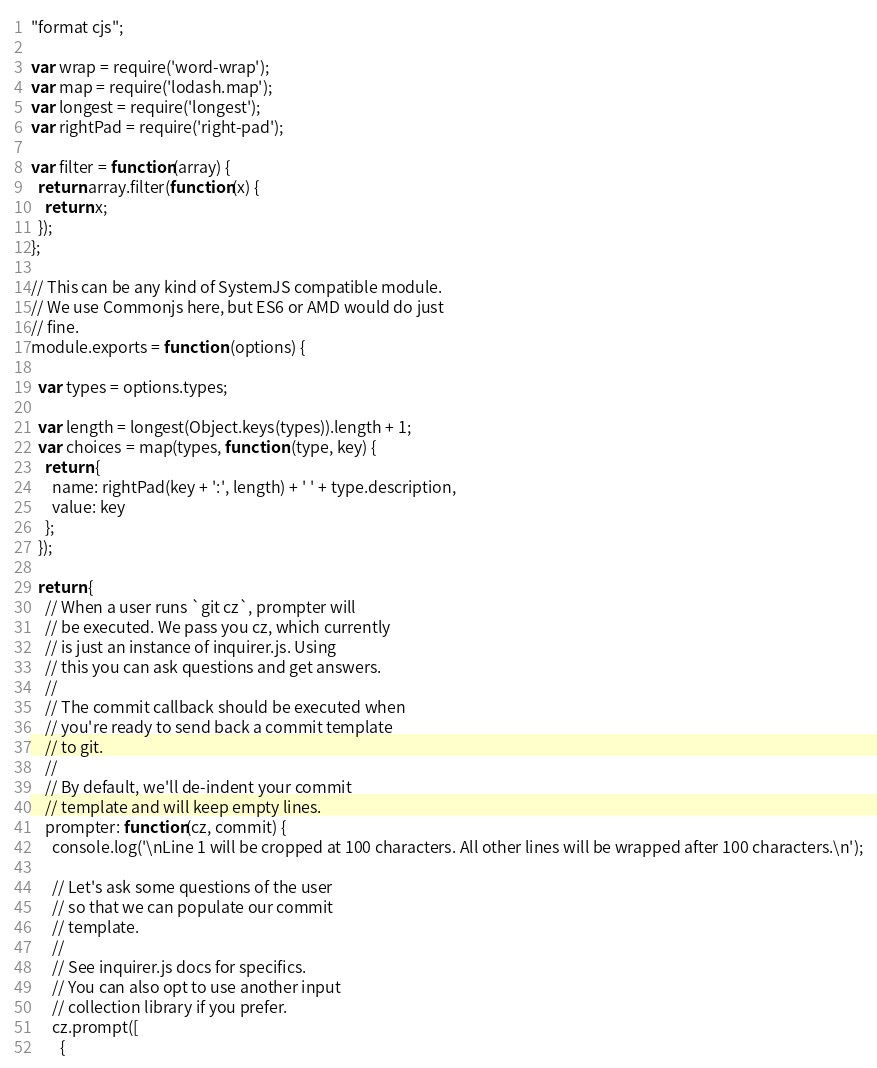Convert code to text. <code><loc_0><loc_0><loc_500><loc_500><_JavaScript_>"format cjs";

var wrap = require('word-wrap');
var map = require('lodash.map');
var longest = require('longest');
var rightPad = require('right-pad');

var filter = function(array) {
  return array.filter(function(x) {
    return x;
  });
};

// This can be any kind of SystemJS compatible module.
// We use Commonjs here, but ES6 or AMD would do just
// fine.
module.exports = function (options) {

  var types = options.types;

  var length = longest(Object.keys(types)).length + 1;
  var choices = map(types, function (type, key) {
    return {
      name: rightPad(key + ':', length) + ' ' + type.description,
      value: key
    };
  });

  return {
    // When a user runs `git cz`, prompter will
    // be executed. We pass you cz, which currently
    // is just an instance of inquirer.js. Using
    // this you can ask questions and get answers.
    //
    // The commit callback should be executed when
    // you're ready to send back a commit template
    // to git.
    //
    // By default, we'll de-indent your commit
    // template and will keep empty lines.
    prompter: function(cz, commit) {
      console.log('\nLine 1 will be cropped at 100 characters. All other lines will be wrapped after 100 characters.\n');

      // Let's ask some questions of the user
      // so that we can populate our commit
      // template.
      //
      // See inquirer.js docs for specifics.
      // You can also opt to use another input
      // collection library if you prefer.
      cz.prompt([
        {</code> 